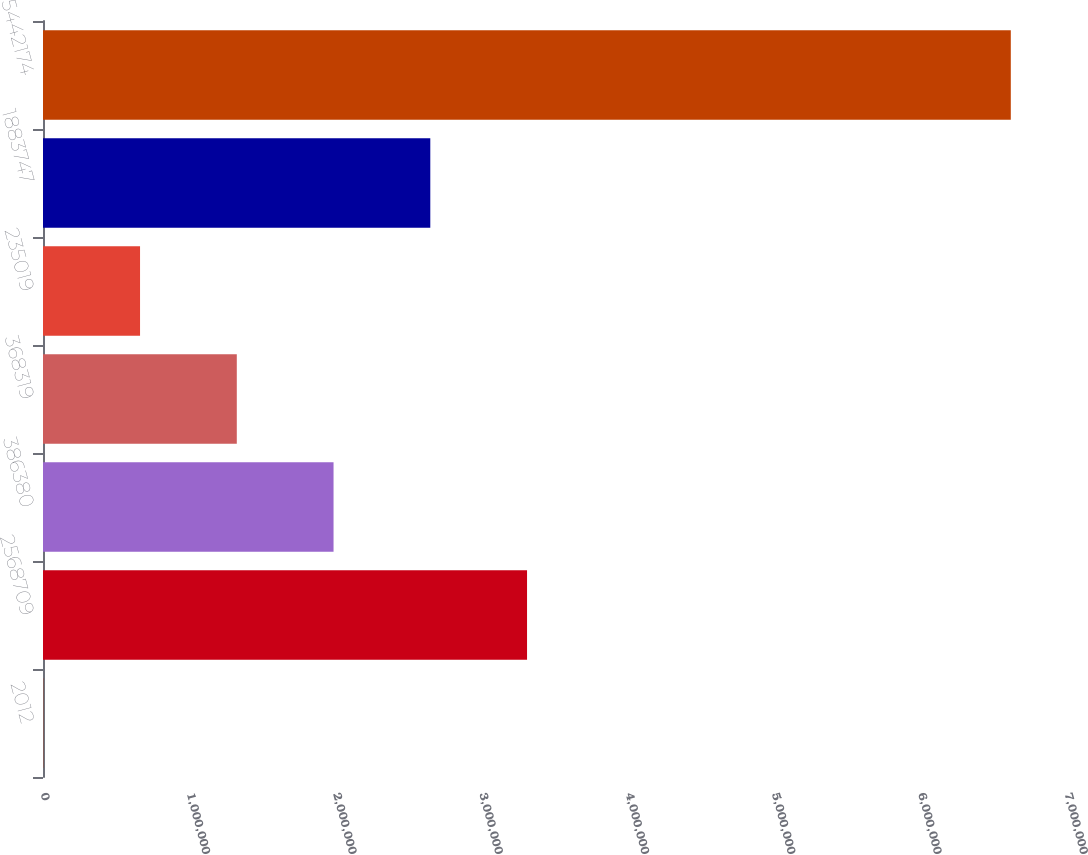<chart> <loc_0><loc_0><loc_500><loc_500><bar_chart><fcel>2012<fcel>2568709<fcel>386380<fcel>368319<fcel>235019<fcel>1883747<fcel>5442174<nl><fcel>2011<fcel>3.30891e+06<fcel>1.98615e+06<fcel>1.32477e+06<fcel>663391<fcel>2.64753e+06<fcel>6.61581e+06<nl></chart> 